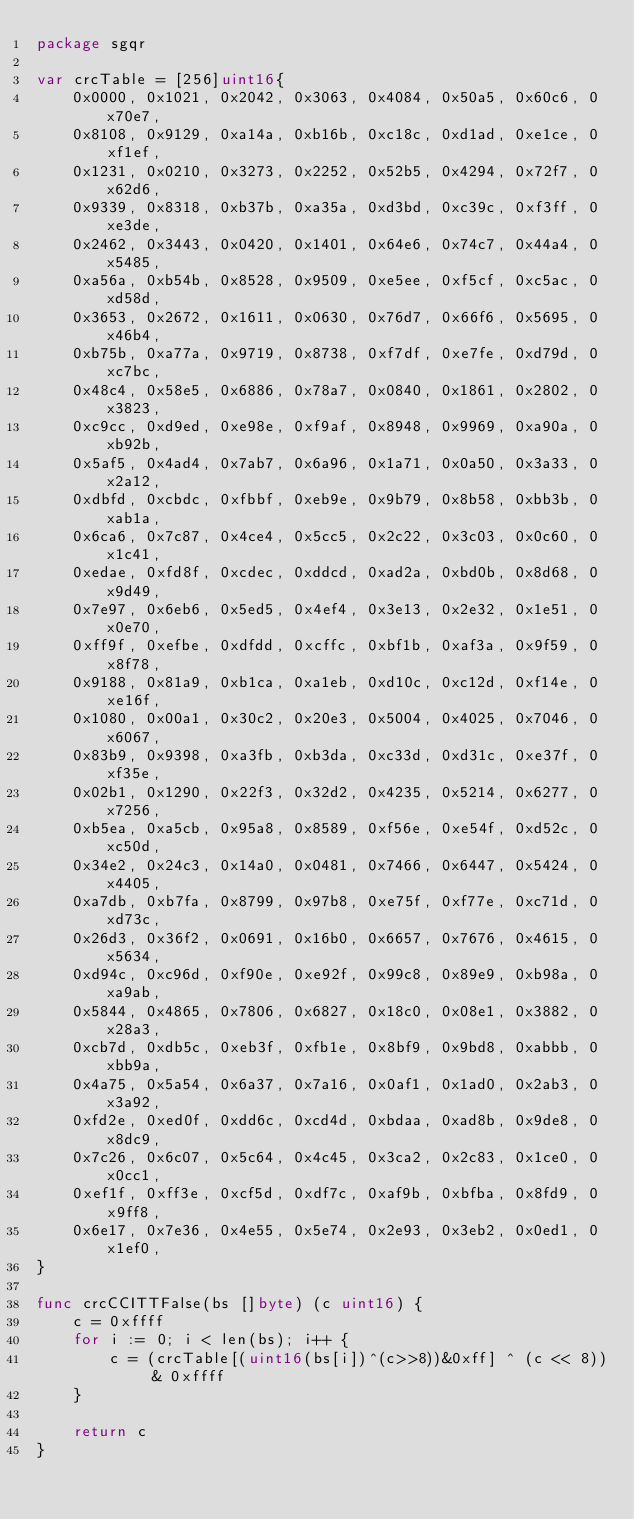<code> <loc_0><loc_0><loc_500><loc_500><_Go_>package sgqr

var crcTable = [256]uint16{
	0x0000, 0x1021, 0x2042, 0x3063, 0x4084, 0x50a5, 0x60c6, 0x70e7,
	0x8108, 0x9129, 0xa14a, 0xb16b, 0xc18c, 0xd1ad, 0xe1ce, 0xf1ef,
	0x1231, 0x0210, 0x3273, 0x2252, 0x52b5, 0x4294, 0x72f7, 0x62d6,
	0x9339, 0x8318, 0xb37b, 0xa35a, 0xd3bd, 0xc39c, 0xf3ff, 0xe3de,
	0x2462, 0x3443, 0x0420, 0x1401, 0x64e6, 0x74c7, 0x44a4, 0x5485,
	0xa56a, 0xb54b, 0x8528, 0x9509, 0xe5ee, 0xf5cf, 0xc5ac, 0xd58d,
	0x3653, 0x2672, 0x1611, 0x0630, 0x76d7, 0x66f6, 0x5695, 0x46b4,
	0xb75b, 0xa77a, 0x9719, 0x8738, 0xf7df, 0xe7fe, 0xd79d, 0xc7bc,
	0x48c4, 0x58e5, 0x6886, 0x78a7, 0x0840, 0x1861, 0x2802, 0x3823,
	0xc9cc, 0xd9ed, 0xe98e, 0xf9af, 0x8948, 0x9969, 0xa90a, 0xb92b,
	0x5af5, 0x4ad4, 0x7ab7, 0x6a96, 0x1a71, 0x0a50, 0x3a33, 0x2a12,
	0xdbfd, 0xcbdc, 0xfbbf, 0xeb9e, 0x9b79, 0x8b58, 0xbb3b, 0xab1a,
	0x6ca6, 0x7c87, 0x4ce4, 0x5cc5, 0x2c22, 0x3c03, 0x0c60, 0x1c41,
	0xedae, 0xfd8f, 0xcdec, 0xddcd, 0xad2a, 0xbd0b, 0x8d68, 0x9d49,
	0x7e97, 0x6eb6, 0x5ed5, 0x4ef4, 0x3e13, 0x2e32, 0x1e51, 0x0e70,
	0xff9f, 0xefbe, 0xdfdd, 0xcffc, 0xbf1b, 0xaf3a, 0x9f59, 0x8f78,
	0x9188, 0x81a9, 0xb1ca, 0xa1eb, 0xd10c, 0xc12d, 0xf14e, 0xe16f,
	0x1080, 0x00a1, 0x30c2, 0x20e3, 0x5004, 0x4025, 0x7046, 0x6067,
	0x83b9, 0x9398, 0xa3fb, 0xb3da, 0xc33d, 0xd31c, 0xe37f, 0xf35e,
	0x02b1, 0x1290, 0x22f3, 0x32d2, 0x4235, 0x5214, 0x6277, 0x7256,
	0xb5ea, 0xa5cb, 0x95a8, 0x8589, 0xf56e, 0xe54f, 0xd52c, 0xc50d,
	0x34e2, 0x24c3, 0x14a0, 0x0481, 0x7466, 0x6447, 0x5424, 0x4405,
	0xa7db, 0xb7fa, 0x8799, 0x97b8, 0xe75f, 0xf77e, 0xc71d, 0xd73c,
	0x26d3, 0x36f2, 0x0691, 0x16b0, 0x6657, 0x7676, 0x4615, 0x5634,
	0xd94c, 0xc96d, 0xf90e, 0xe92f, 0x99c8, 0x89e9, 0xb98a, 0xa9ab,
	0x5844, 0x4865, 0x7806, 0x6827, 0x18c0, 0x08e1, 0x3882, 0x28a3,
	0xcb7d, 0xdb5c, 0xeb3f, 0xfb1e, 0x8bf9, 0x9bd8, 0xabbb, 0xbb9a,
	0x4a75, 0x5a54, 0x6a37, 0x7a16, 0x0af1, 0x1ad0, 0x2ab3, 0x3a92,
	0xfd2e, 0xed0f, 0xdd6c, 0xcd4d, 0xbdaa, 0xad8b, 0x9de8, 0x8dc9,
	0x7c26, 0x6c07, 0x5c64, 0x4c45, 0x3ca2, 0x2c83, 0x1ce0, 0x0cc1,
	0xef1f, 0xff3e, 0xcf5d, 0xdf7c, 0xaf9b, 0xbfba, 0x8fd9, 0x9ff8,
	0x6e17, 0x7e36, 0x4e55, 0x5e74, 0x2e93, 0x3eb2, 0x0ed1, 0x1ef0,
}

func crcCCITTFalse(bs []byte) (c uint16) {
	c = 0xffff
	for i := 0; i < len(bs); i++ {
		c = (crcTable[(uint16(bs[i])^(c>>8))&0xff] ^ (c << 8)) & 0xffff
	}

	return c
}
</code> 